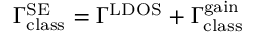Convert formula to latex. <formula><loc_0><loc_0><loc_500><loc_500>\Gamma _ { c l a s s } ^ { S E } = \Gamma ^ { L D O S } + \Gamma _ { c l a s s } ^ { g a i n }</formula> 